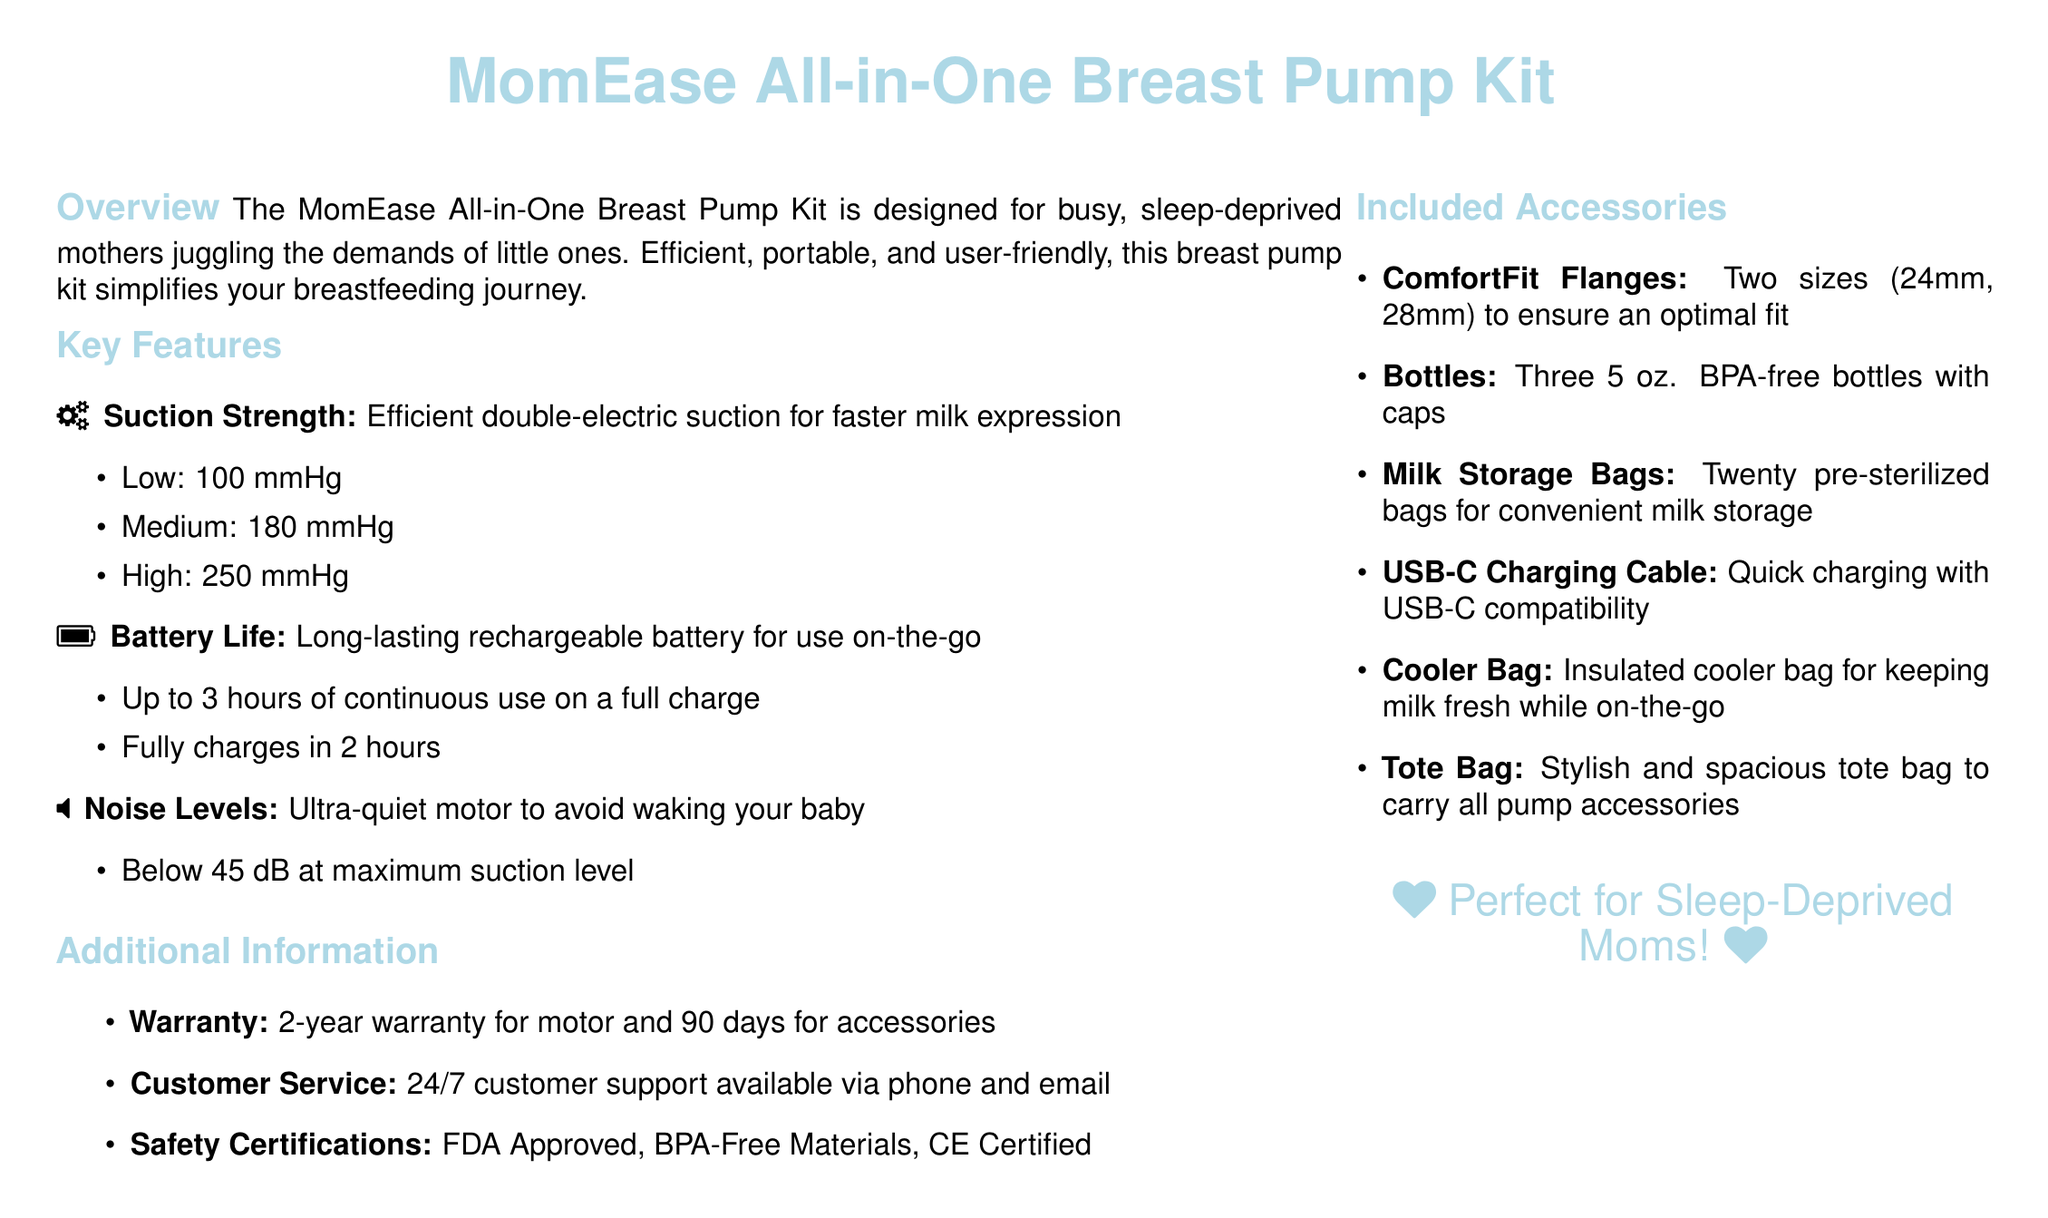What is the suction strength on high? The document states that the high suction strength is 250 mmHg.
Answer: 250 mmHg How long can the breast pump be used on a full charge? The document mentions that the breast pump can be used for up to 3 hours on a full charge.
Answer: 3 hours What is the noise level at maximum suction? The document specifies that the noise level is below 45 dB at maximum suction.
Answer: Below 45 dB What are the sizes of the ComfortFit Flanges included? The document indicates that the ComfortFit Flanges come in two sizes: 24mm and 28mm.
Answer: 24mm, 28mm How long does it take to fully charge the breast pump? According to the document, it takes 2 hours to fully charge the breast pump.
Answer: 2 hours What type of certification does the breast pump have? The document lists FDA Approved, BPA-Free Materials, and CE Certified as safety certifications.
Answer: FDA Approved, BPA-Free Materials, CE Certified What type of charging cable is included? The document states that the included charging cable is USB-C.
Answer: USB-C What warranty is provided for the motor? The document mentions a 2-year warranty for the motor.
Answer: 2-year warranty How many milk storage bags are included? The document states that there are twenty pre-sterilized milk storage bags included.
Answer: Twenty 